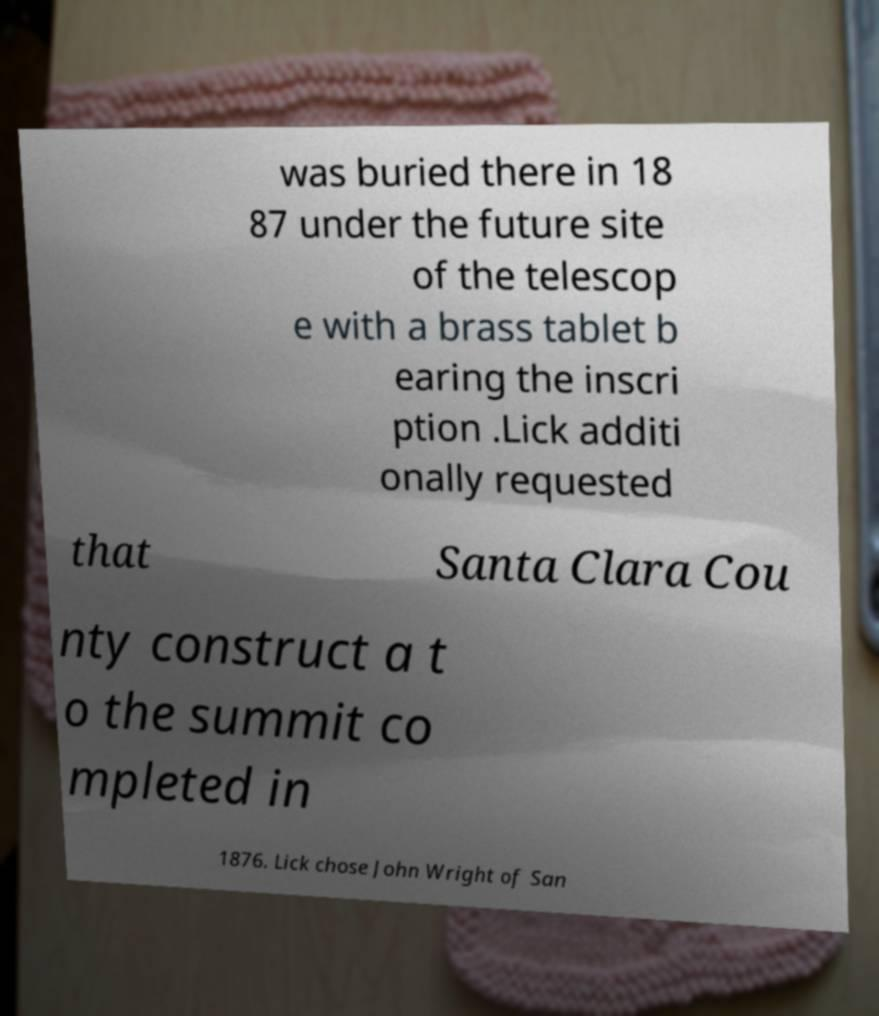Could you assist in decoding the text presented in this image and type it out clearly? was buried there in 18 87 under the future site of the telescop e with a brass tablet b earing the inscri ption .Lick additi onally requested that Santa Clara Cou nty construct a t o the summit co mpleted in 1876. Lick chose John Wright of San 